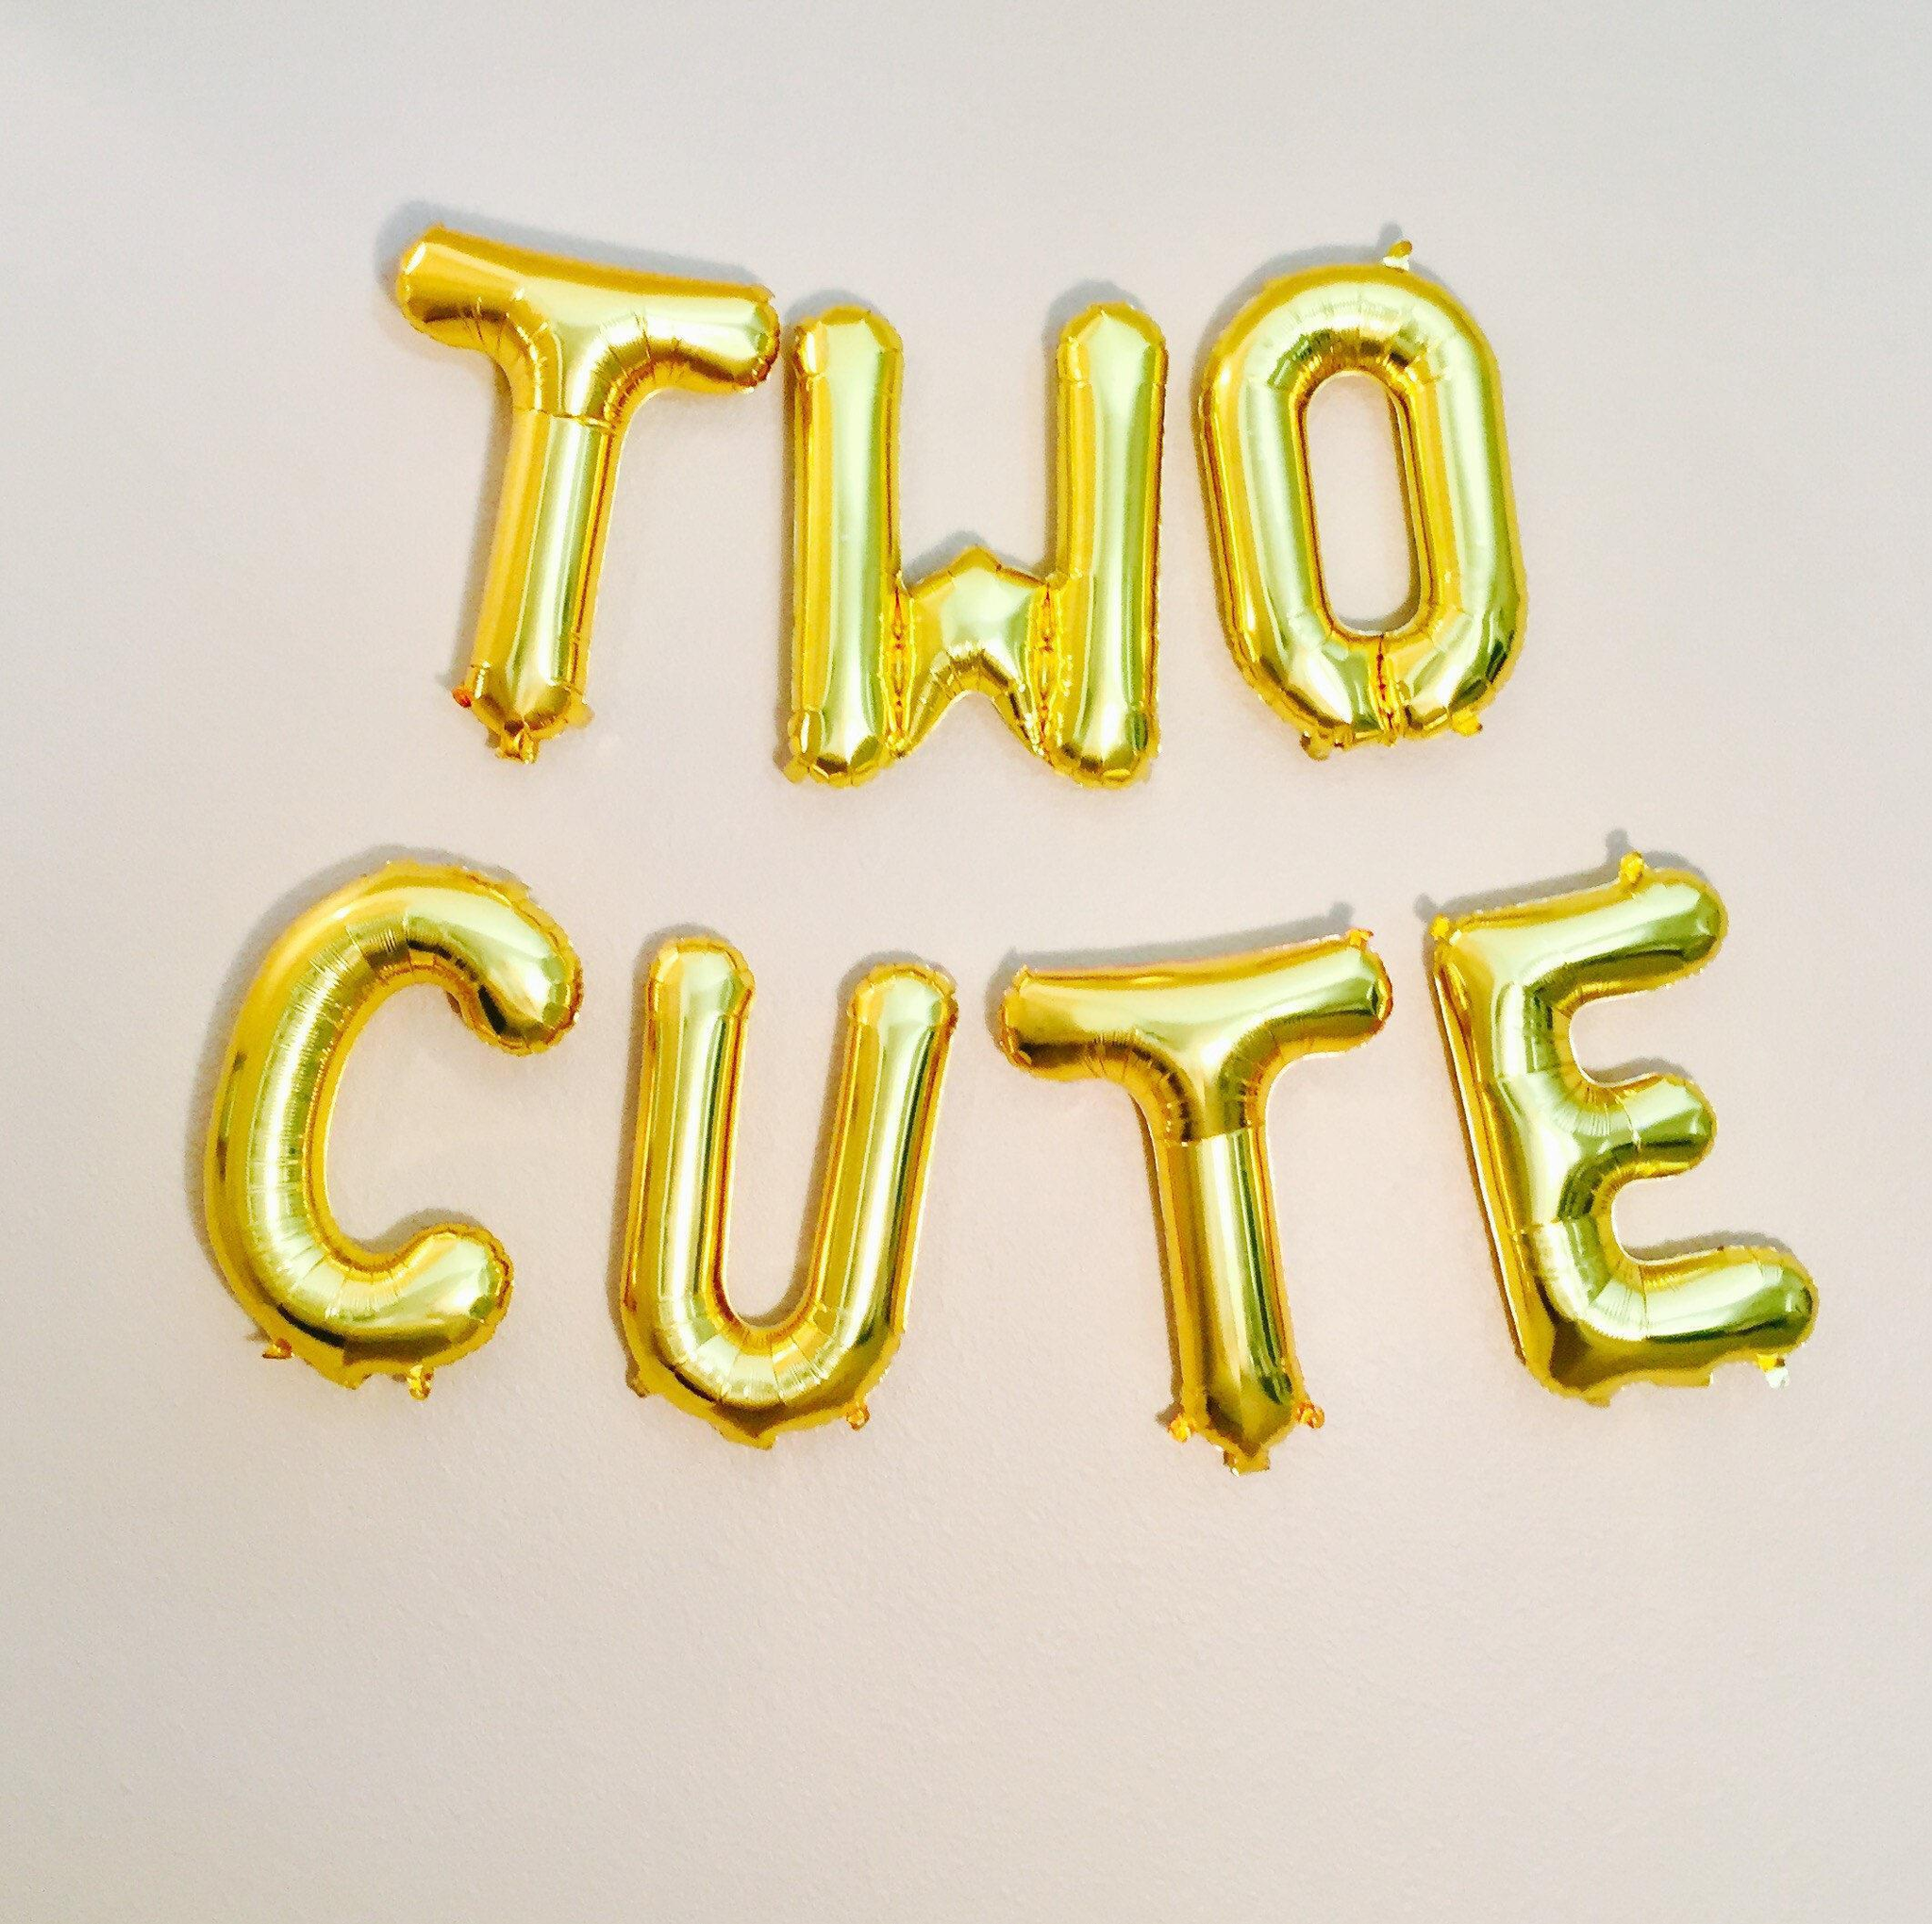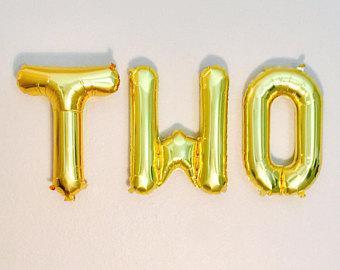The first image is the image on the left, the second image is the image on the right. For the images shown, is this caption "One of the balloons is shaped like the number 2." true? Answer yes or no. No. The first image is the image on the left, the second image is the image on the right. Given the left and right images, does the statement "One image shows a balloon shaped like the number 2, along with other balloons." hold true? Answer yes or no. No. 